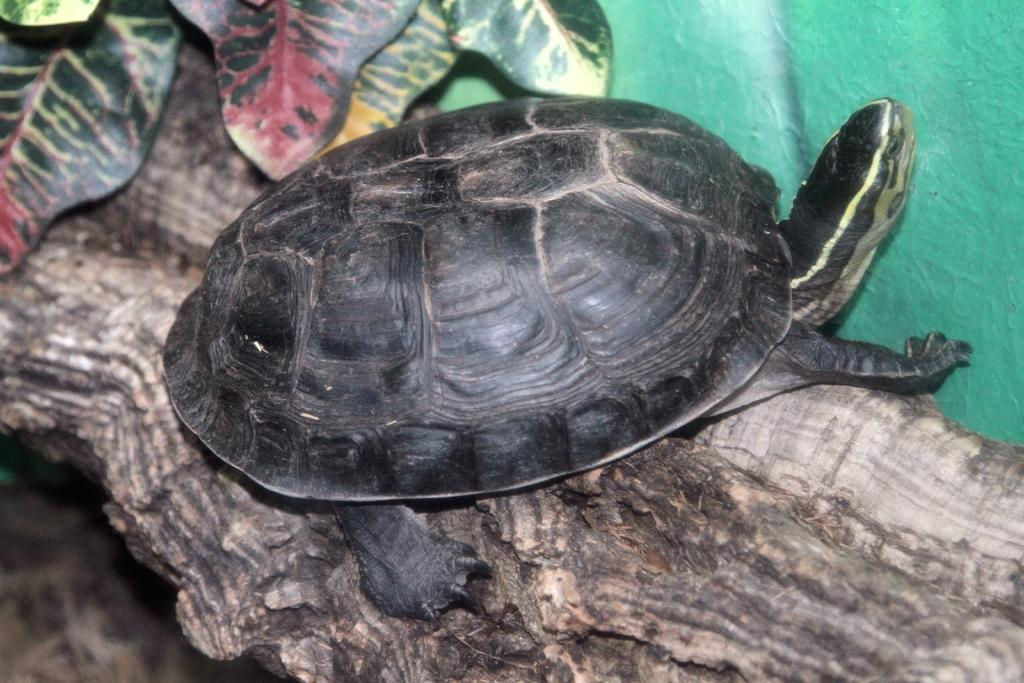What animal is present in the image? There is a tortoise in the image. Where is the tortoise located? The tortoise is on a tree trunk. What can be seen at the top of the image? There are leaves visible at the top of the image. How does the tortoise contribute to the earthquake in the image? There is no earthquake present in the image, and the tortoise's actions do not cause any earthquake. 